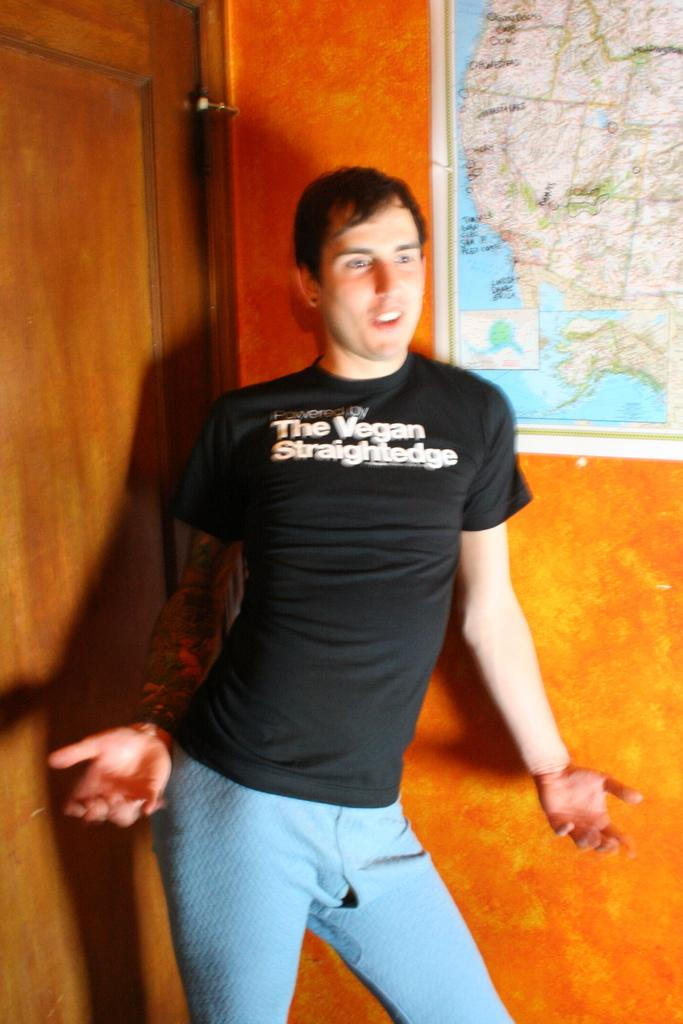<image>
Relay a brief, clear account of the picture shown. a man with a Vegan shirt on himself. 